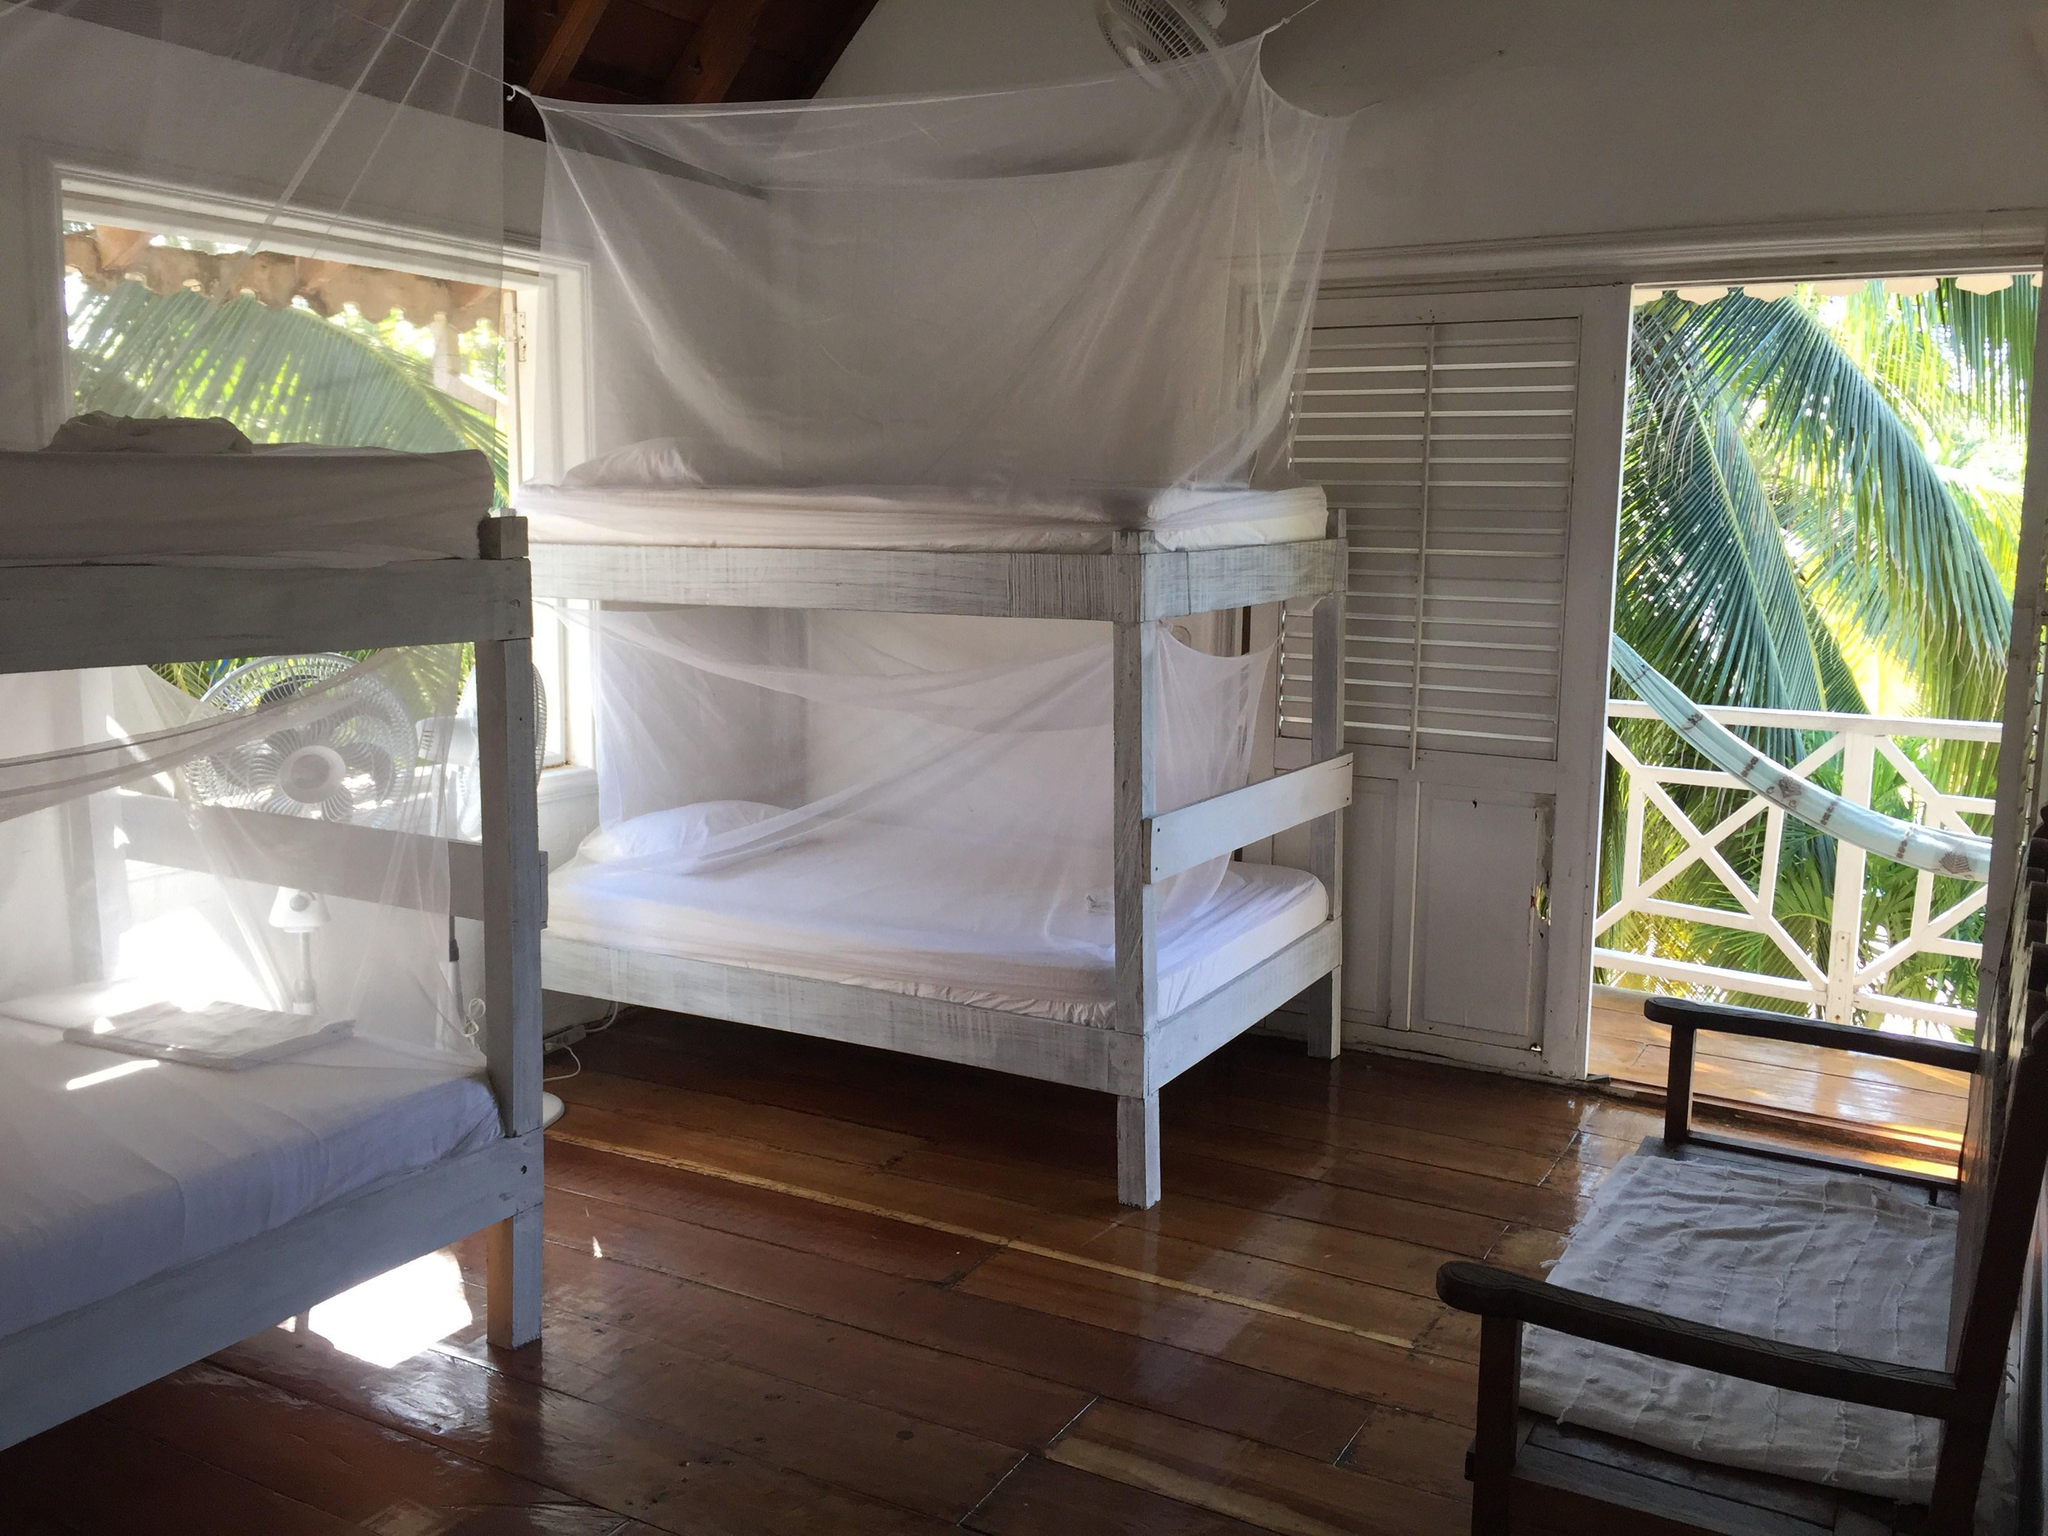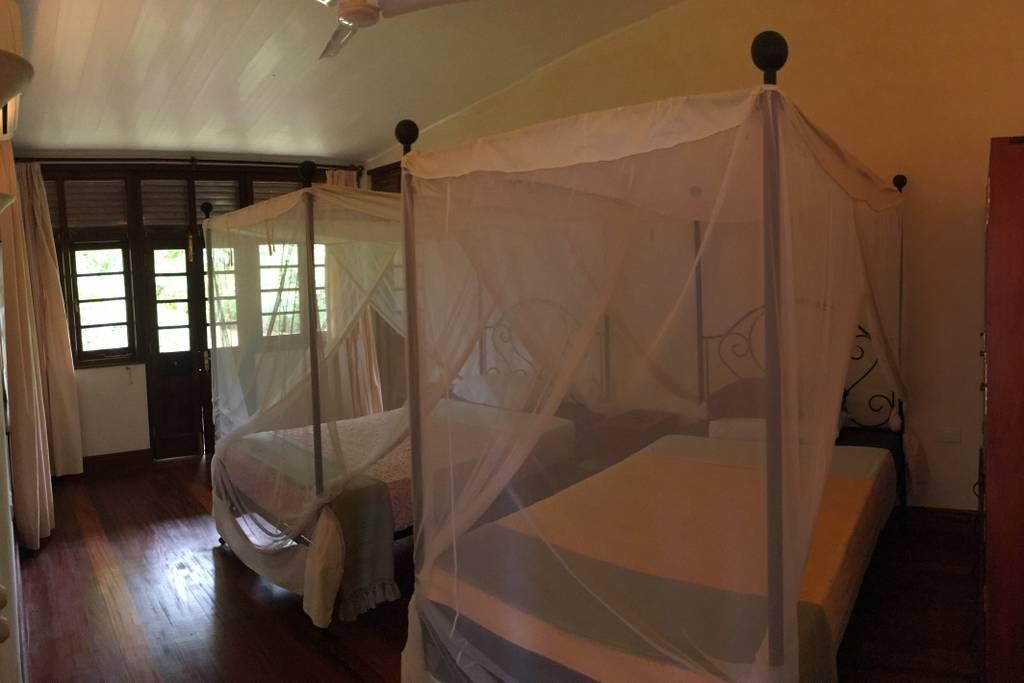The first image is the image on the left, the second image is the image on the right. For the images displayed, is the sentence "At least one image shows a room with multiple beds equipped with some type of protective screens." factually correct? Answer yes or no. Yes. The first image is the image on the left, the second image is the image on the right. Evaluate the accuracy of this statement regarding the images: "There are two beds in one of the images.". Is it true? Answer yes or no. Yes. 